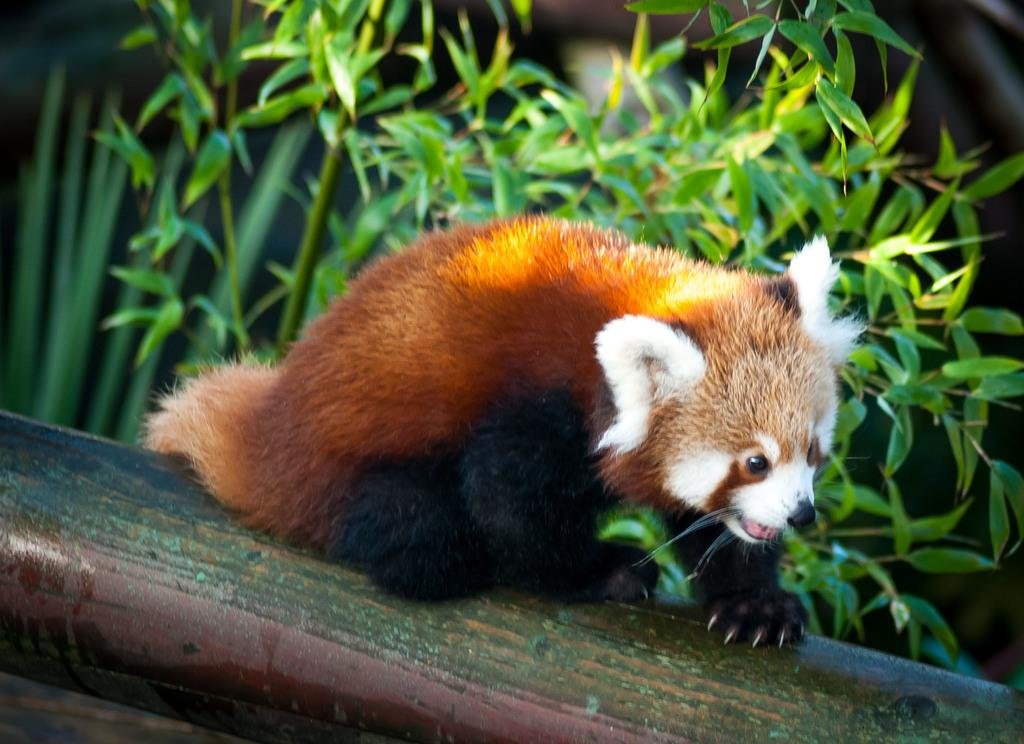What type of animal is in the image? There is a Red Panda in the image. What is the Red Panda resting on? The Red Panda is on a surface. What else can be seen in the image besides the Red Panda? There are plants in the image. What color is the sweater the Red Panda is wearing in the image? The Red Panda is not wearing a sweater in the image; it is a wild animal and does not wear clothing. 